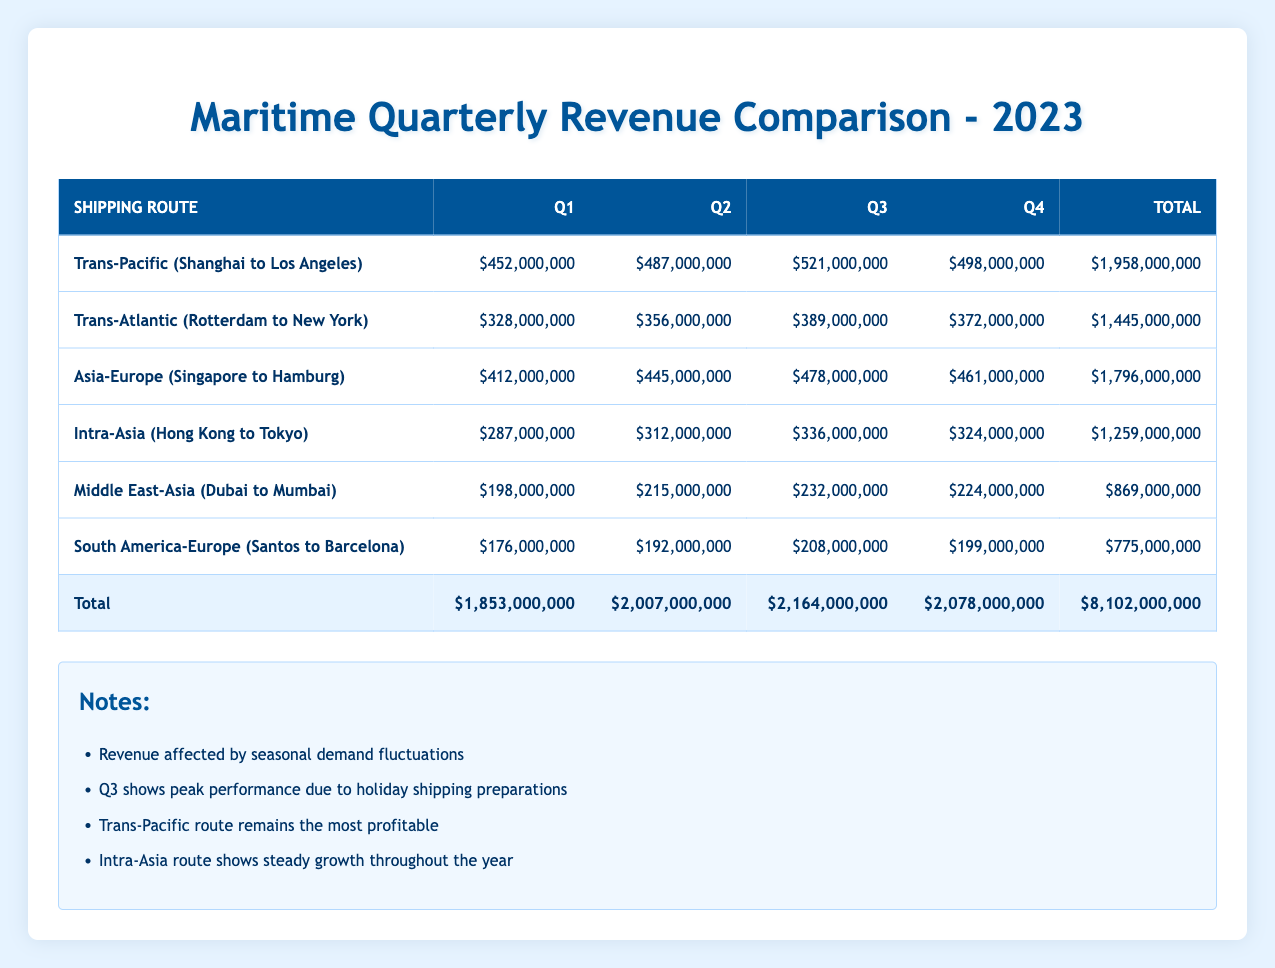What was the highest revenue recorded in Q3? From the table, looking at the Q3 column, the revenues for each route are as follows: Trans-Pacific (521000000), Trans-Atlantic (389000000), Asia-Europe (478000000), Intra-Asia (336000000), Middle East-Asia (232000000), and South America-Europe (208000000). The highest among these is Trans-Pacific with 521000000.
Answer: 521000000 Which shipping route had the lowest total revenue for the year? The total revenues for the routes are: Trans-Pacific (1958000000), Trans-Atlantic (1445000000), Asia-Europe (1796000000), Intra-Asia (1259000000), Middle East-Asia (869000000), and South America-Europe (775000000). The lowest total revenue is for South America-Europe with 775000000.
Answer: South America-Europe What is the average revenue for the Trans-Atlantic route across all quarters? The quarterly revenues for the Trans-Atlantic route are: 328000000, 356000000, 389000000, and 372000000. Summing these values gives 1445000000, then dividing by 4 gives an average of 361250000.
Answer: 361250000 Did the Intra-Asia shipping route show growth from Q1 to Q4? The revenues for the Intra-Asia route are: Q1 (287000000), Q2 (312000000), Q3 (336000000), and Q4 (324000000). From Q1 to Q3, there is growth, but from Q3 to Q4 it decreased. Thus, it did not show consistent growth throughout all quarters.
Answer: No What is the total revenue from all shipping routes in Q2? The revenues in Q2 for all routes are: Trans-Pacific (487000000), Trans-Atlantic (356000000), Asia-Europe (445000000), Intra-Asia (312000000), Middle East-Asia (215000000), and South America-Europe (192000000). Summing these gives a total of 1986000000.
Answer: 1986000000 Which quarter had the highest total revenue across all shipping routes? The total revenues for each quarter are: Q1 (1853000000), Q2 (2007000000), Q3 (2164000000), and Q4 (2078000000). Q3 has the highest total revenue of 2164000000.
Answer: Q3 Was the revenue for the Middle East-Asia route above 200 million in every quarter? The revenues for the Middle East-Asia route are as follows: Q1 (198000000), Q2 (215000000), Q3 (232000000), and Q4 (224000000). Q1 does not exceed 200 million, so the statement is false.
Answer: No What percentage of the total yearly revenue did the Trans-Pacific route represent? The total revenue for all routes is 8102000000 and the Trans-Pacific route earns 1958000000. To find the percentage: (1958000000 / 8102000000) * 100 = approximately 24.16%.
Answer: 24.16% 